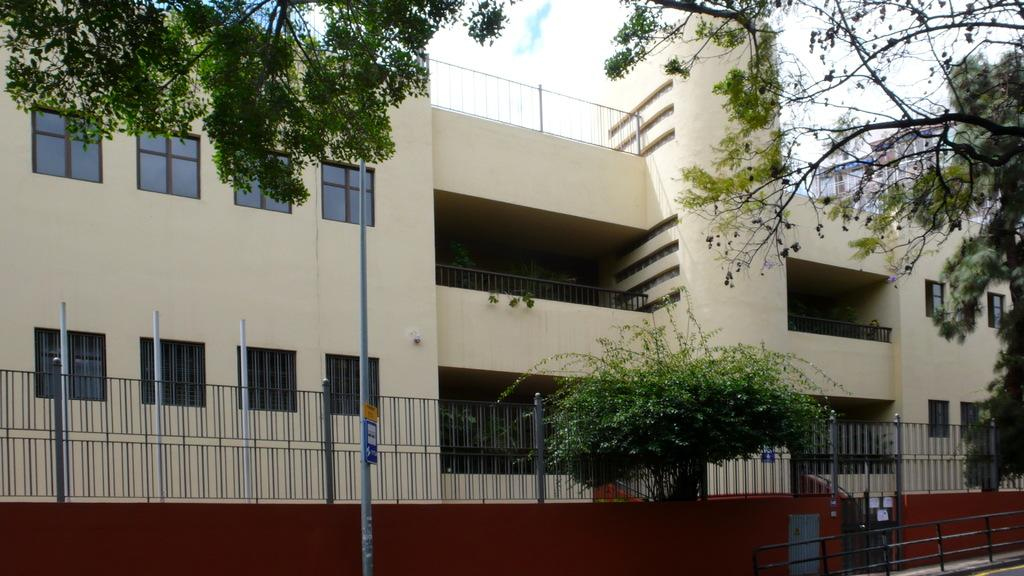What type of structure is present in the image? There is a building with windows in the image. What is the purpose of the fence in the image? The purpose of the fence is not explicitly stated, but it could be for security or to mark boundaries. What is attached to the pole in the image? There is a board attached to a pole in the image. What type of vegetation is present in the image? Plants and trees are present in the image. What is visible in the sky in the image? The sky is visible in the image and appears cloudy. What type of work is being done on the wish system in the image? There is no mention of a wish system or any work being done in the image. The image primarily features a building, fence, board, plants, trees, and a cloudy sky. 